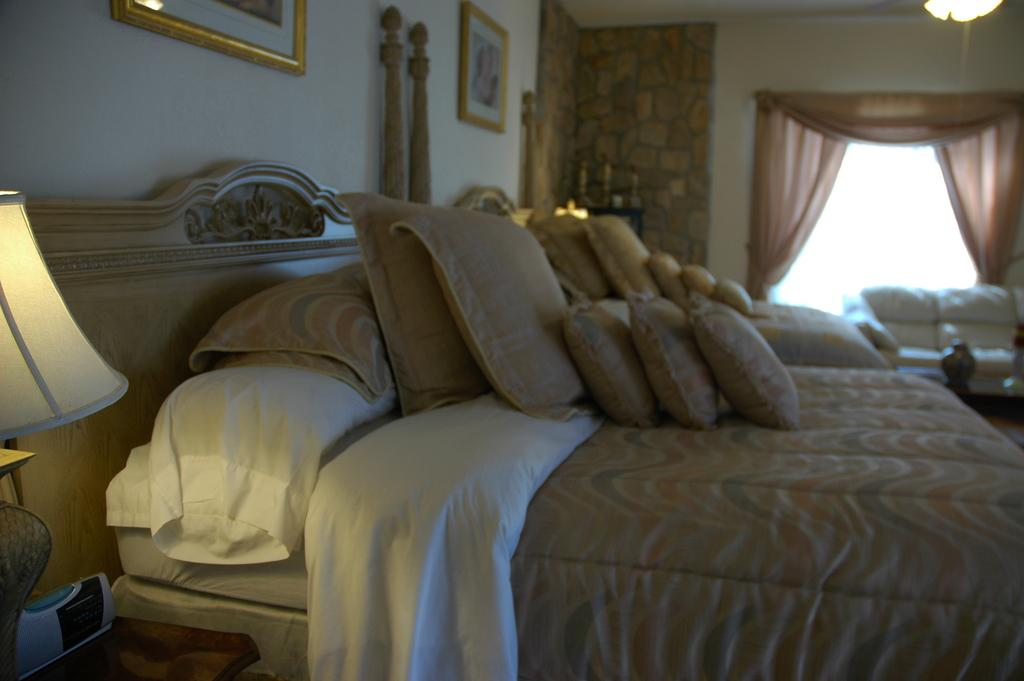What type of room is depicted in the image? The image depicts a bedroom. What is the main piece of furniture in the bedroom? There is a bed in the bedroom. What items can be seen on the bed? Pillows and blankets are present on the bed. Can you describe the lighting in the bedroom? There is a lamp on the left side of the bedroom. What can be seen in the background of the bedroom? Curtains, a window, a sofa, and a wall are visible in the background. What type of cloth is being used to gain knowledge in the image? There is no cloth or knowledge-gaining activity depicted in the image. Can you tell me how many men are present in the image? There is no man present in the image; it depicts a bedroom with various furniture and decorations. 